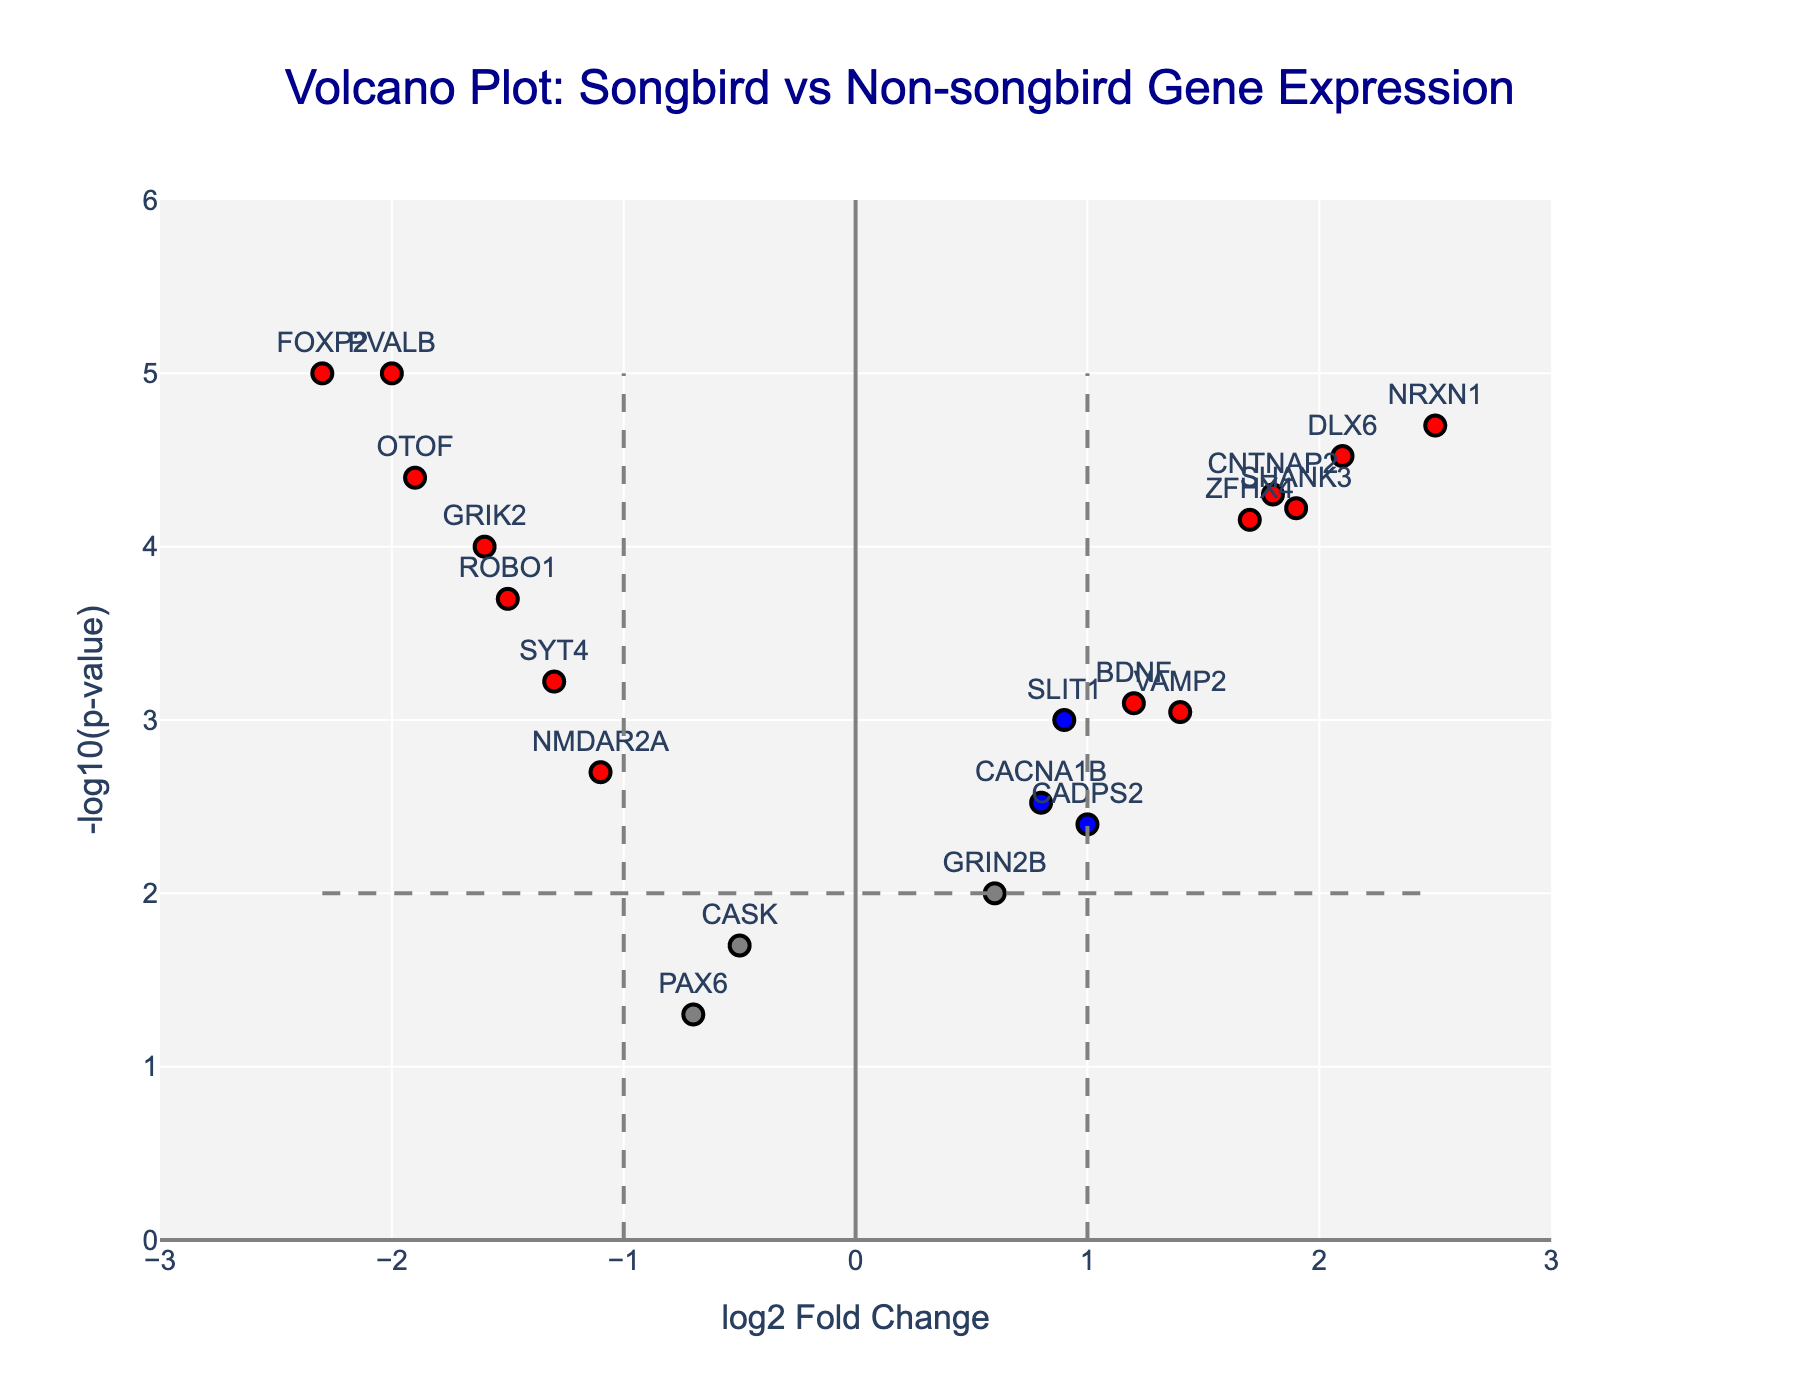How many genes show a significant differential expression (red color) between songbirds and non-songbirds? To determine this, count the number of red-colored points on the plot. These represent genes with log2 fold changes exceeding ±1 and p-values below 0.01.
Answer: 9 What is the full title of the volcano plot? Look at the top of the plot where the title is displayed.
Answer: Volcano Plot: Songbird vs Non-songbird Gene Expression Which gene has the highest negative log2 fold change and a significant p-value? Identify the point with the lowest x-value among the red-colored points. Hover text can help confirm the gene name.
Answer: FOXP2 Which genes have both log2 fold changes greater than 1.5 and highly significant p-values (red color)? Check the red-colored points and filter for those with x-values greater than 1.5. Confirm using hover text which shows both log2FoldChange and p-value.
Answer: DLX6, NRXN1, SHANK3 How many genes have log2 fold changes between -1 and 1 and significant p-values (blue color)? Count the number of blue-colored points which represent genes with log2 fold changes within ±1 and p-values less than 0.01.
Answer: 3 What is the y-axis label in the volcano plot? This can be found along the vertical axis of the plot.
Answer: -log10(p-value) Which gene is the closest to the center of the plot? Look for the gene whose point is nearest to the origin (0,0) in both x and y directions.
Answer: PAX6 What is the log2 fold change and p-value for the gene VAMP2? Locate this gene on the plot by hovering over its point to see its hover text.
Answer: log2 Fold Change: 1.4, p-value: 0.0009 Which gene has the third-highest -log10(p-value)? Rank the points by their y-values and use the hover text to find the third highest.
Answer: CNTNAP2 